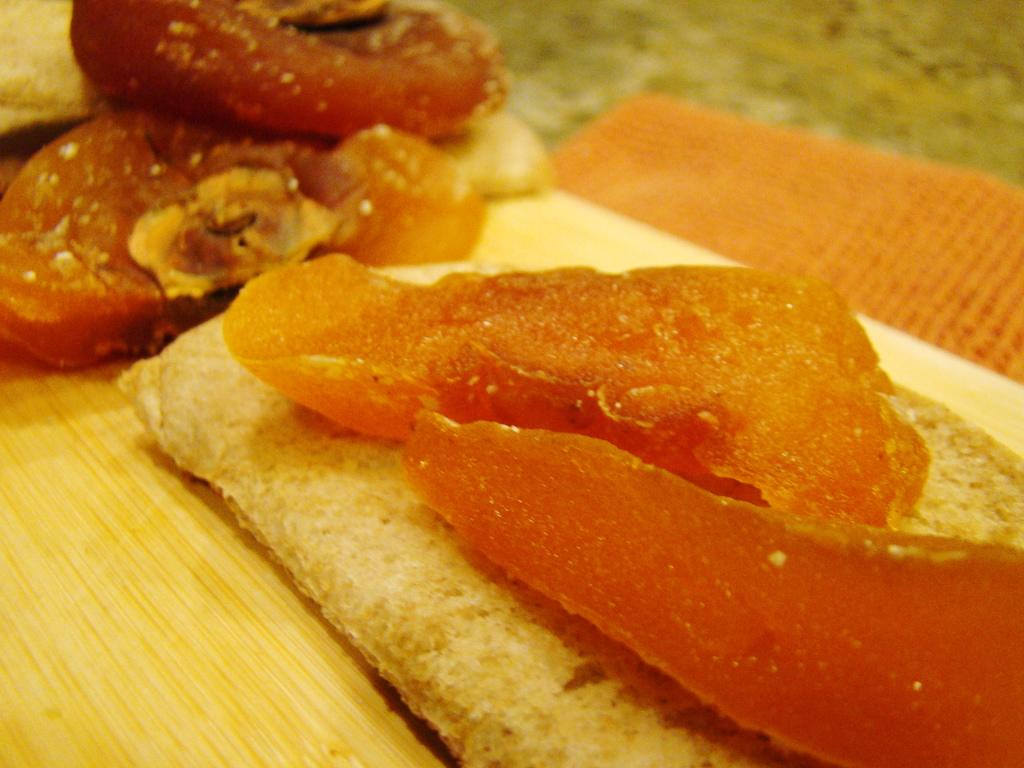What is placed on the wooden platform in the image? There is food on a wooden platform in the image. Can you describe anything in the background of the image? There is an orange object in the background of the image. What type of crime is being committed in the image? There is no indication of any crime being committed in the image. How many minutes does it take for the food to be consumed in the image? The image does not show the food being consumed, so it is impossible to determine how many minutes it would take. 